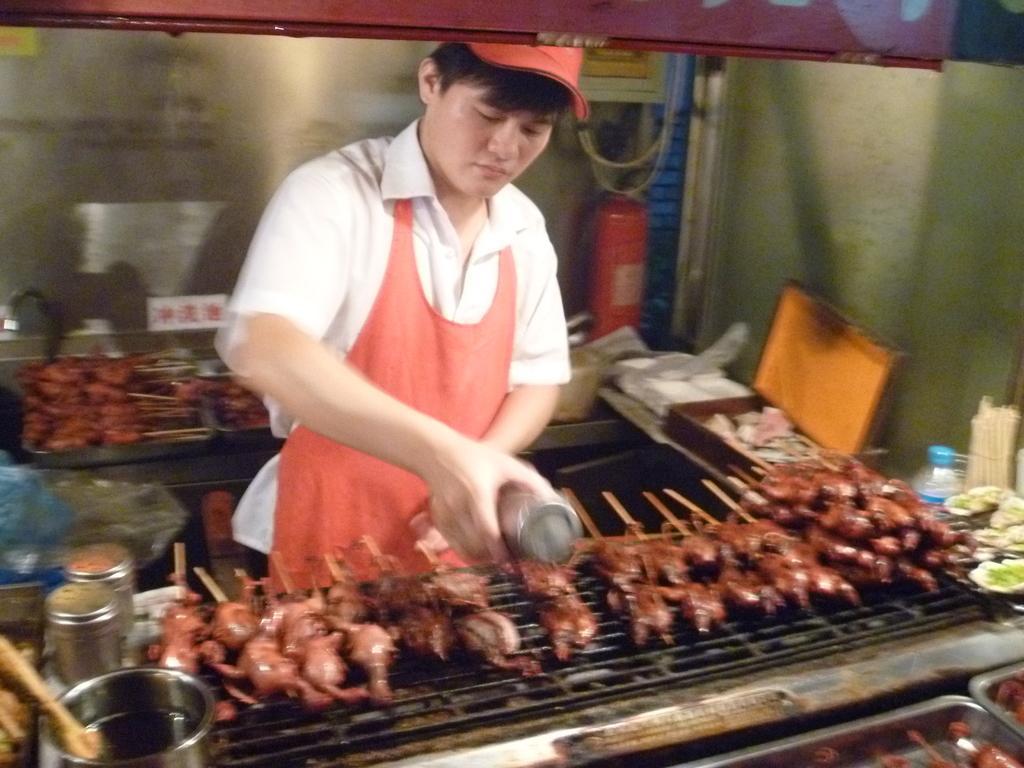Can you describe this image briefly? In the foreground I can see a person is holding an object in hand, bottles, oil, vegetables, trays and meat sticks on a grill. In the background I can see a wall, fire extinguisher and so on. This image is taken may be in a room. 